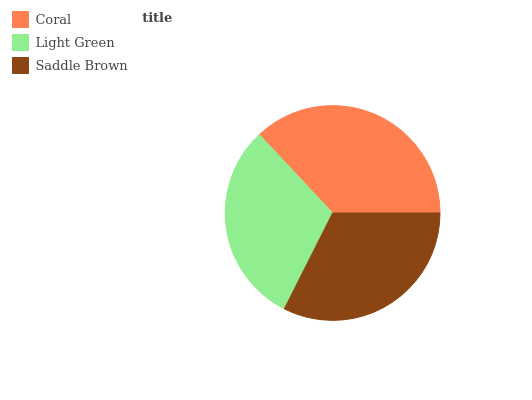Is Light Green the minimum?
Answer yes or no. Yes. Is Coral the maximum?
Answer yes or no. Yes. Is Saddle Brown the minimum?
Answer yes or no. No. Is Saddle Brown the maximum?
Answer yes or no. No. Is Saddle Brown greater than Light Green?
Answer yes or no. Yes. Is Light Green less than Saddle Brown?
Answer yes or no. Yes. Is Light Green greater than Saddle Brown?
Answer yes or no. No. Is Saddle Brown less than Light Green?
Answer yes or no. No. Is Saddle Brown the high median?
Answer yes or no. Yes. Is Saddle Brown the low median?
Answer yes or no. Yes. Is Light Green the high median?
Answer yes or no. No. Is Light Green the low median?
Answer yes or no. No. 